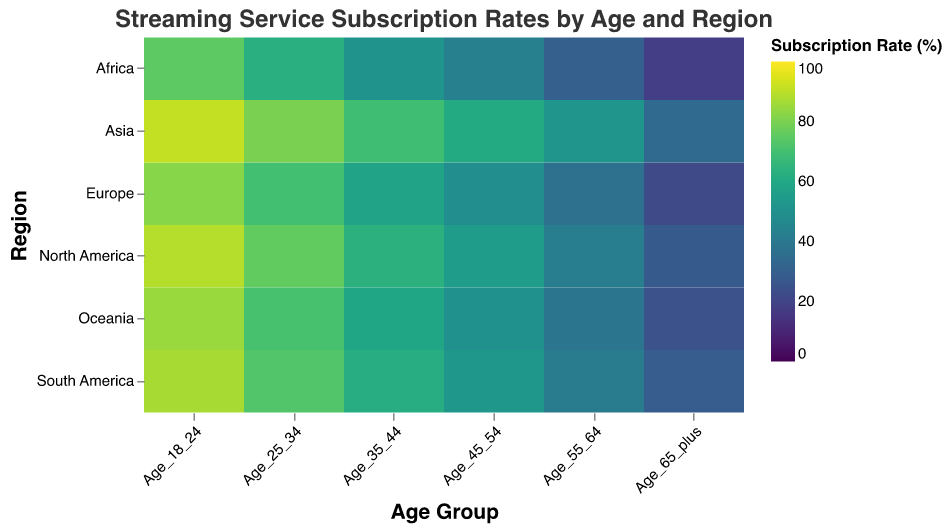What is the title of the heatmap? The title is positioned at the top of the chart and summarizes the purpose of the figure, which is to show the rates of streaming service subscriptions categorized by age and region.
Answer: Streaming Service Subscription Rates by Age and Region Which age group in Asia has the highest subscription rate? By looking at the color intensity in the Asia row, the darkest color, indicating the highest subscription rate, is found in the Age_18_24 column.
Answer: Age_18_24 Which region has the lowest subscription rate for the Age_65_plus group? The lightest-colored cell in the Age_65_plus column, which represents the lowest subscription rate for this age group, is found in the Africa row.
Answer: Africa What is the average subscription rate for the Age_25_34 group across all regions? Sum the subscription rates for the Age_25_34 group across all regions (76 + 70 + 80 + 73 + 63 + 71) and divide by the number of regions. The sum is 433, and the average is 433/6 = 72.2
Answer: 72.2 Which region shows the highest drop in subscription rates between Age_18_24 and Age_65_plus? Calculate the difference in subscription rates between Age_18_24 and Age_65_plus for each region. North America: 89-28=61, Europe: 82-22=60, Asia: 91-34=57, South America: 87-29=58, Africa: 75-18=57, Oceania: 85-25=60. The highest drop is in North America with a difference of 61.
Answer: North America How does the subscription rate for Age_35_44 in Europe compare to that in South America? Look at the cells corresponding to Age_35_44 in the rows for Europe and South America. The subscription rate for Age_35_44 in Europe is 58, and in South America, it is 62. South America's rate is higher.
Answer: South America Which age group shows the least variation in subscription rates across different regions? Identify which column shows the least color variation. Age_25_34 column appears relatively uniform in color intensity, suggesting minor variation in subscription rates across regions.
Answer: Age_25_34 What is the range of subscription rates for the Age_55_64 group? Identify the highest and lowest subscription rates in the Age_55_64 column. The highest rate is in Asia (52) and the lowest is in Africa (30). The range is 52 - 30 = 22.
Answer: 22 Which two regions have subscription rates that differ the most for the Age_45_54 group? Compare the subscription rates for Age_45_54 in each region. North America (55), Europe (49), Asia (61), South America (53), Africa (43), Oceania (50). The maximum difference is between Africa (43) and Asia (61) with a difference of 18.
Answer: Africa and Asia 